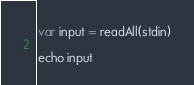<code> <loc_0><loc_0><loc_500><loc_500><_Nim_>
var input = readAll(stdin)

echo input</code> 